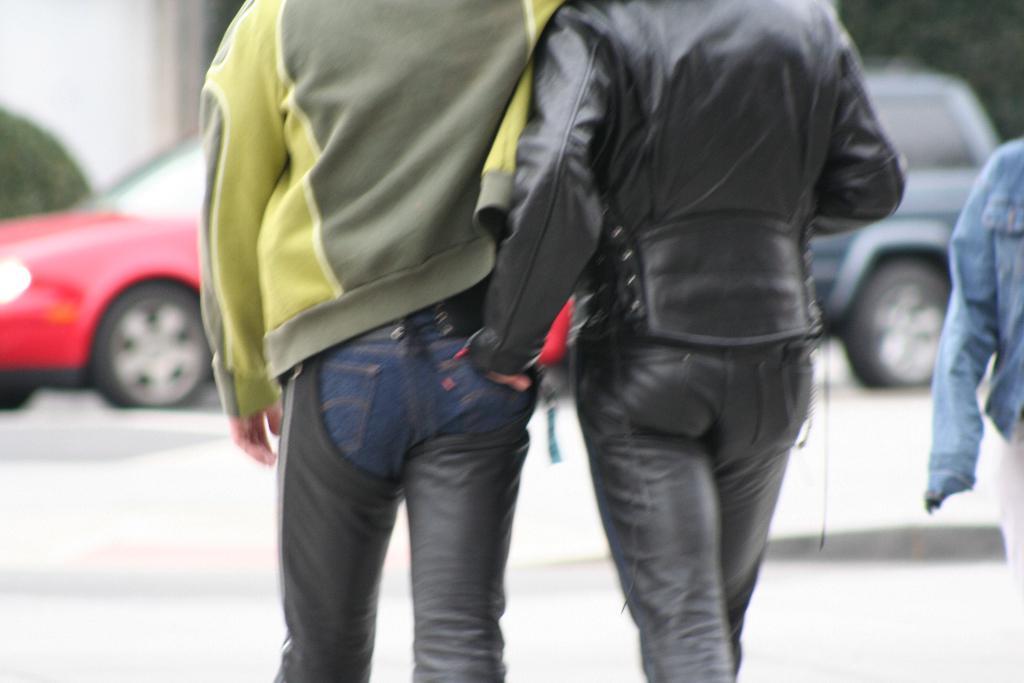Describe this image in one or two sentences. In this image we can see persons, motor vehicles on the road. In the background we can see trees and walls. 